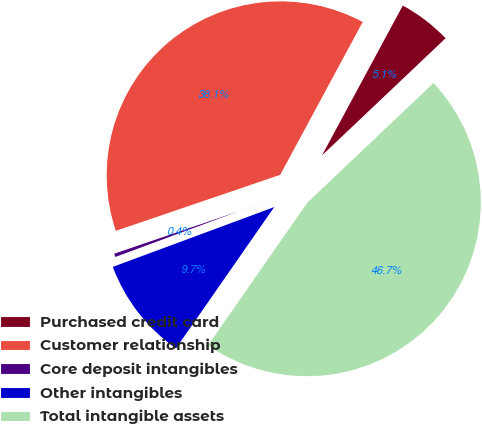Convert chart. <chart><loc_0><loc_0><loc_500><loc_500><pie_chart><fcel>Purchased credit card<fcel>Customer relationship<fcel>Core deposit intangibles<fcel>Other intangibles<fcel>Total intangible assets<nl><fcel>5.05%<fcel>38.1%<fcel>0.42%<fcel>9.68%<fcel>46.74%<nl></chart> 